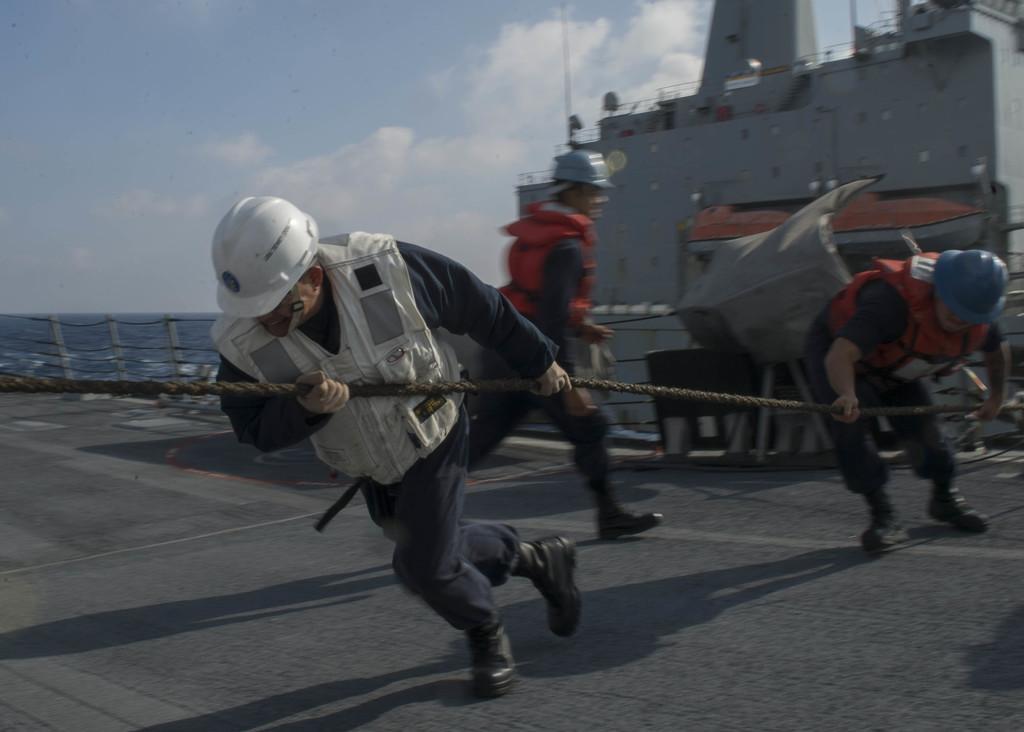How would you summarize this image in a sentence or two? In this picture we can see a ship, in the background there is water, we can see two persons are holding a rope and a person is walking, these three persons wore helmets, shoes and life jackets, there is the sky and clouds at the top of the picture. 